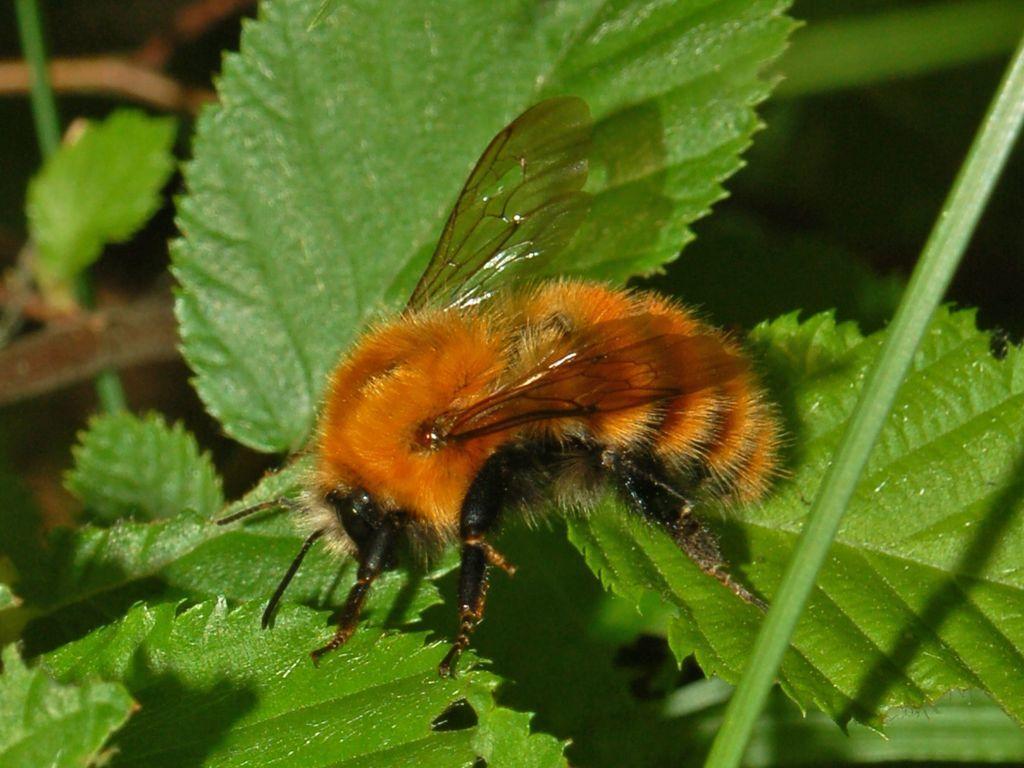Describe this image in one or two sentences. In this image I can see a bee on the leaves. On the right side there is a stem. The background is blurred. 